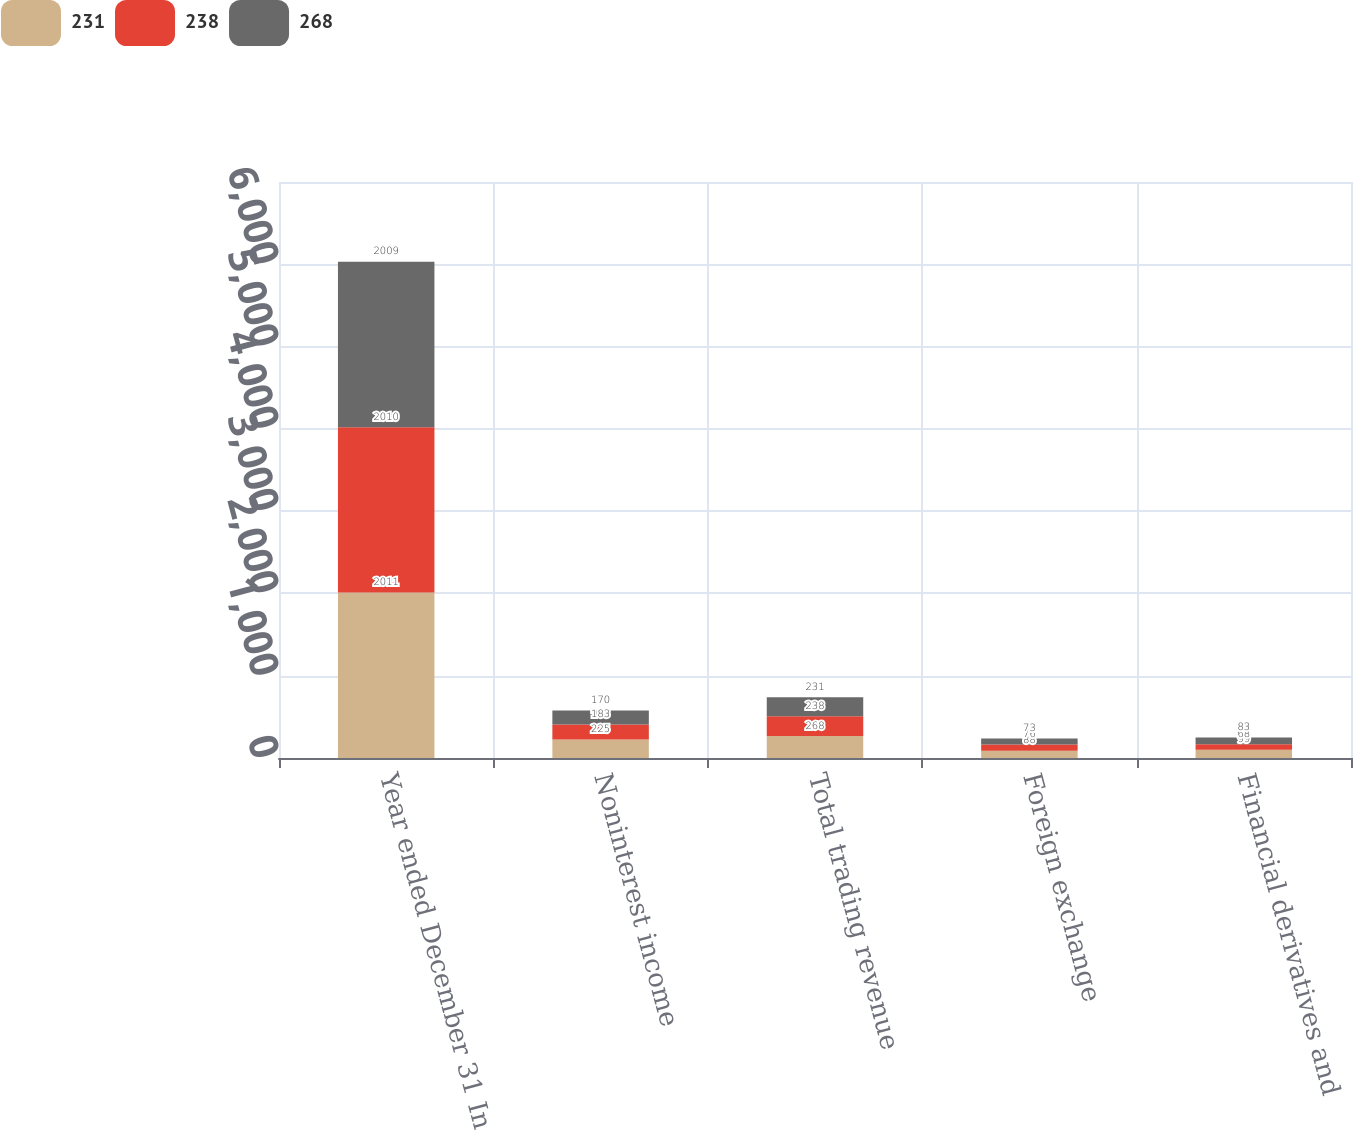Convert chart to OTSL. <chart><loc_0><loc_0><loc_500><loc_500><stacked_bar_chart><ecel><fcel>Year ended December 31 In<fcel>Noninterest income<fcel>Total trading revenue<fcel>Foreign exchange<fcel>Financial derivatives and<nl><fcel>231<fcel>2011<fcel>225<fcel>268<fcel>88<fcel>99<nl><fcel>238<fcel>2010<fcel>183<fcel>238<fcel>76<fcel>68<nl><fcel>268<fcel>2009<fcel>170<fcel>231<fcel>73<fcel>83<nl></chart> 